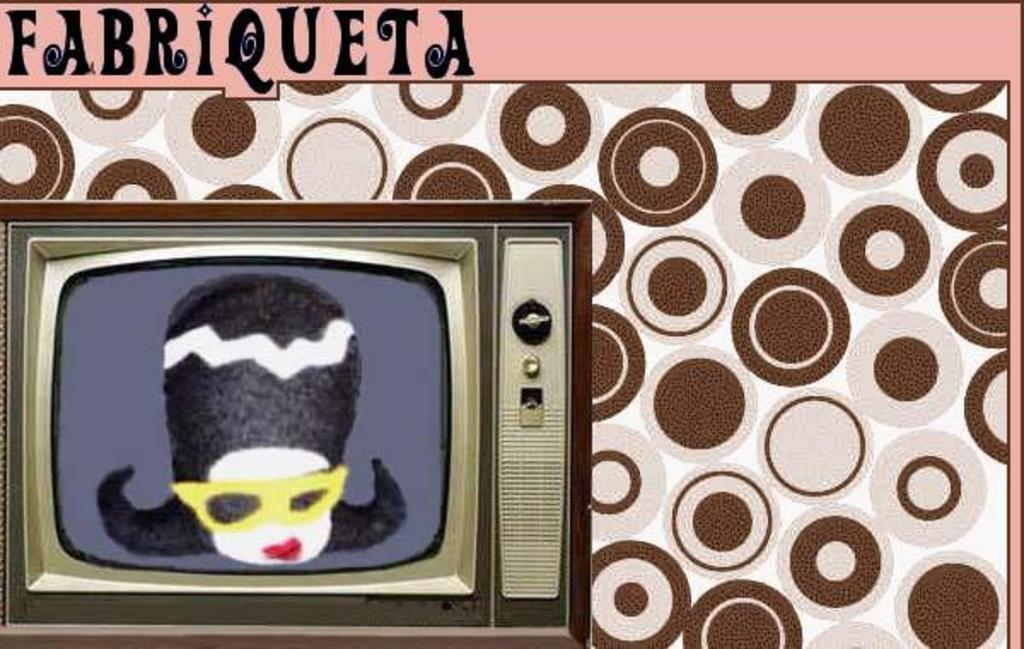What is the main object in the image? There is a television in the image. What is being displayed on the television screen? The television screen is displaying a cartoon image. Can you describe the background of the cartoon image? There is a designed background on the screen. Where is the text located in the image? There is text in the top left corner of the image. How many pairs of shoes are visible in the image? There are no shoes present in the image; it features a television displaying a cartoon image. What type of cars can be seen driving in the background of the image? There are no cars present in the image; it features a television displaying a cartoon image with a designed background. 